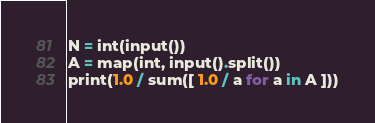<code> <loc_0><loc_0><loc_500><loc_500><_Python_>N = int(input())
A = map(int, input().split())
print(1.0 / sum([ 1.0 / a for a in A ]))</code> 